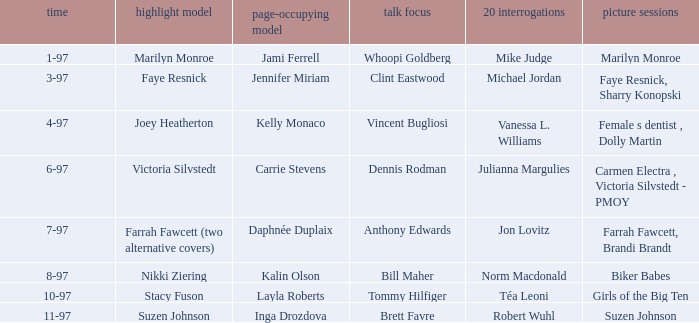Who was the interview subject on the date 1-97? Whoopi Goldberg. 